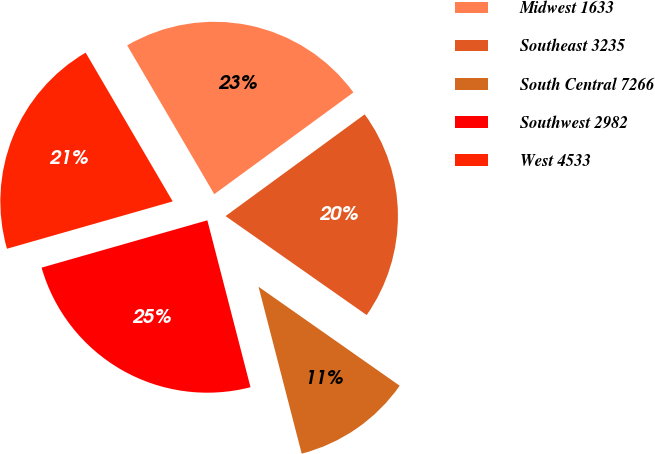<chart> <loc_0><loc_0><loc_500><loc_500><pie_chart><fcel>Midwest 1633<fcel>Southeast 3235<fcel>South Central 7266<fcel>Southwest 2982<fcel>West 4533<nl><fcel>23.38%<fcel>19.78%<fcel>11.24%<fcel>24.6%<fcel>21.0%<nl></chart> 